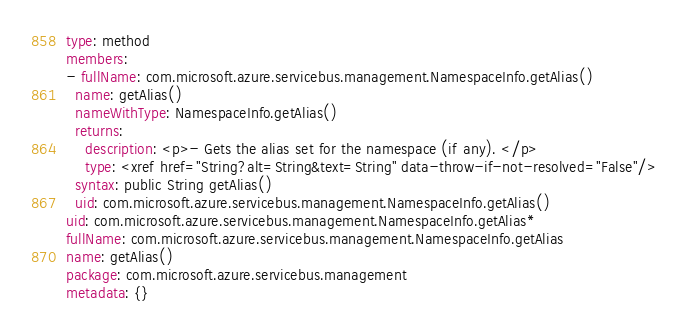<code> <loc_0><loc_0><loc_500><loc_500><_YAML_>type: method
members:
- fullName: com.microsoft.azure.servicebus.management.NamespaceInfo.getAlias()
  name: getAlias()
  nameWithType: NamespaceInfo.getAlias()
  returns:
    description: <p>- Gets the alias set for the namespace (if any). </p>
    type: <xref href="String?alt=String&text=String" data-throw-if-not-resolved="False"/>
  syntax: public String getAlias()
  uid: com.microsoft.azure.servicebus.management.NamespaceInfo.getAlias()
uid: com.microsoft.azure.servicebus.management.NamespaceInfo.getAlias*
fullName: com.microsoft.azure.servicebus.management.NamespaceInfo.getAlias
name: getAlias()
package: com.microsoft.azure.servicebus.management
metadata: {}
</code> 